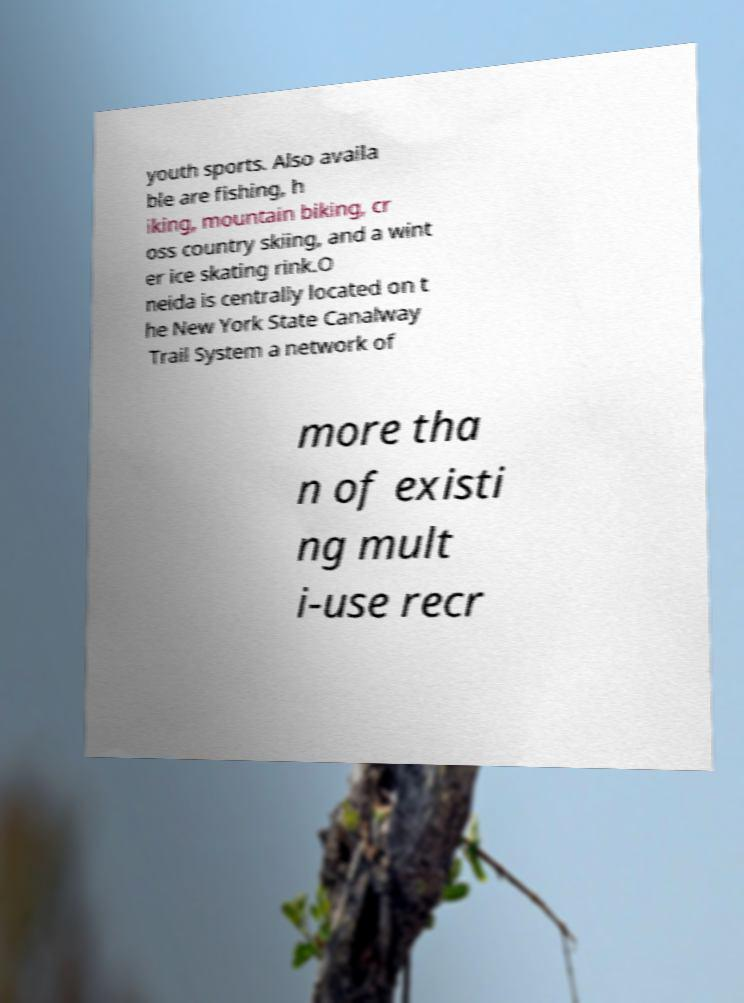Please read and relay the text visible in this image. What does it say? youth sports. Also availa ble are fishing, h iking, mountain biking, cr oss country skiing, and a wint er ice skating rink.O neida is centrally located on t he New York State Canalway Trail System a network of more tha n of existi ng mult i-use recr 